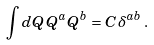Convert formula to latex. <formula><loc_0><loc_0><loc_500><loc_500>\int d Q \, Q ^ { a } Q ^ { b } = C \, \delta ^ { a b } \, .</formula> 